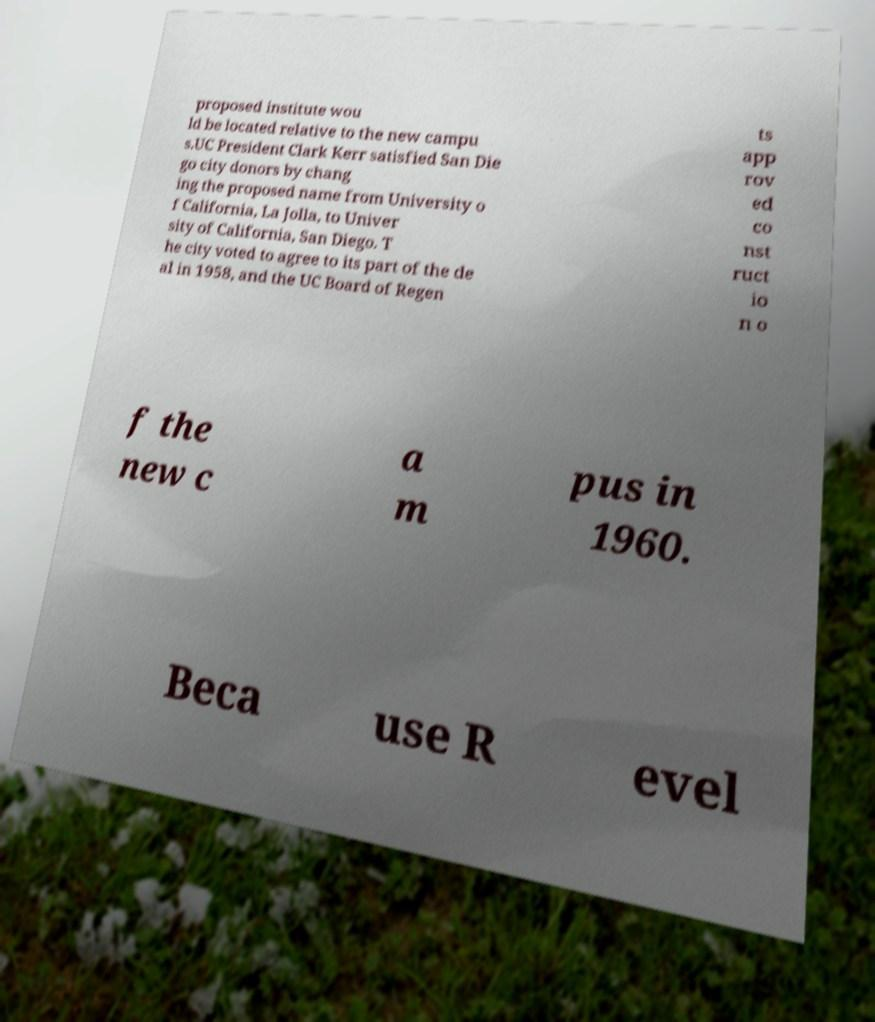Can you accurately transcribe the text from the provided image for me? proposed institute wou ld be located relative to the new campu s.UC President Clark Kerr satisfied San Die go city donors by chang ing the proposed name from University o f California, La Jolla, to Univer sity of California, San Diego. T he city voted to agree to its part of the de al in 1958, and the UC Board of Regen ts app rov ed co nst ruct io n o f the new c a m pus in 1960. Beca use R evel 